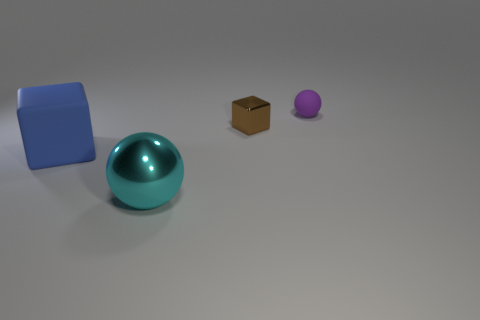Add 1 blocks. How many objects exist? 5 Subtract 0 brown balls. How many objects are left? 4 Subtract all cyan cubes. Subtract all green cylinders. How many cubes are left? 2 Subtract all yellow cubes. How many brown balls are left? 0 Subtract all brown cubes. Subtract all tiny things. How many objects are left? 1 Add 4 matte balls. How many matte balls are left? 5 Add 2 big cyan objects. How many big cyan objects exist? 3 